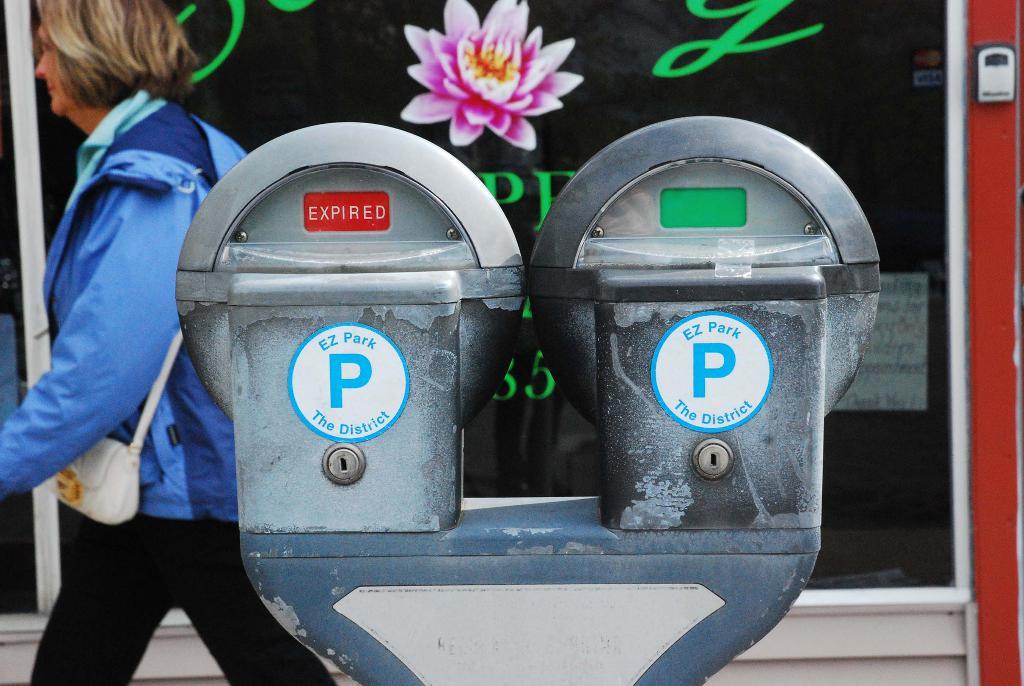Is the parking meter expired on the left or right?
Offer a terse response. Left. What is written in red?
Offer a terse response. Expired. 